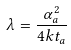<formula> <loc_0><loc_0><loc_500><loc_500>\lambda = \frac { \alpha _ { a } ^ { 2 } } { 4 k t _ { a } }</formula> 